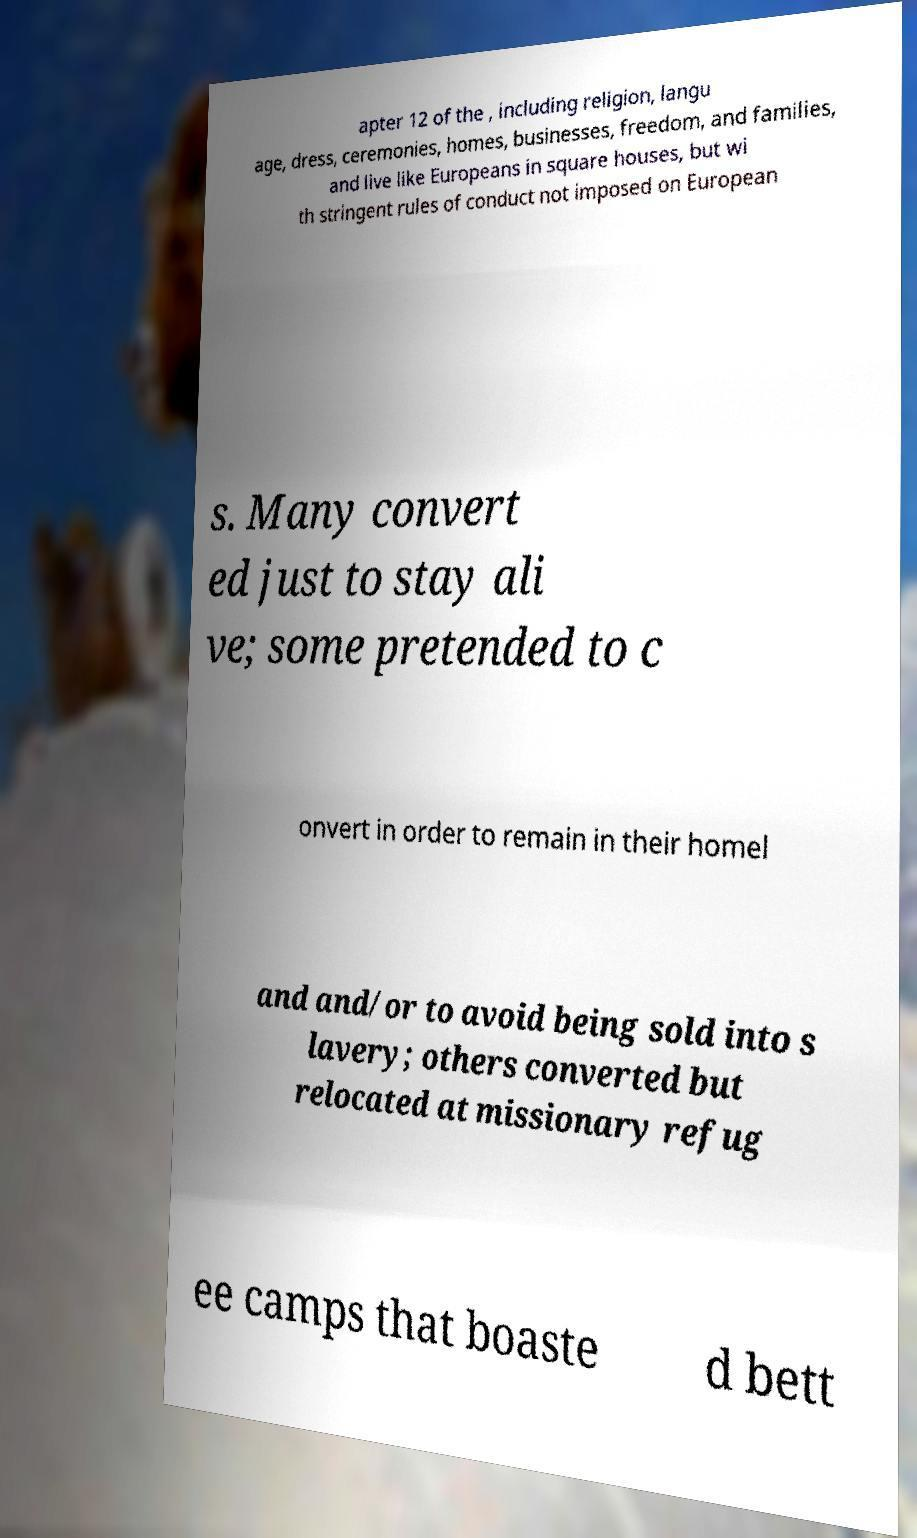Please read and relay the text visible in this image. What does it say? apter 12 of the , including religion, langu age, dress, ceremonies, homes, businesses, freedom, and families, and live like Europeans in square houses, but wi th stringent rules of conduct not imposed on European s. Many convert ed just to stay ali ve; some pretended to c onvert in order to remain in their homel and and/or to avoid being sold into s lavery; others converted but relocated at missionary refug ee camps that boaste d bett 